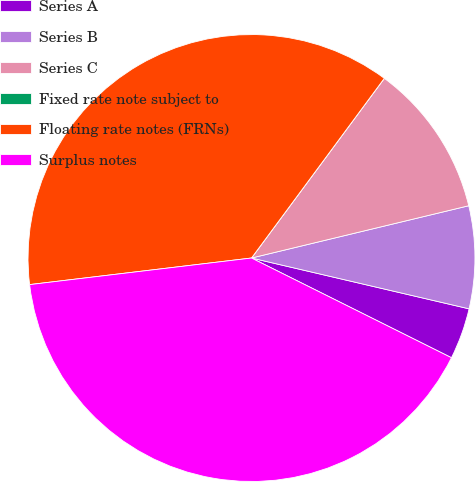Convert chart to OTSL. <chart><loc_0><loc_0><loc_500><loc_500><pie_chart><fcel>Series A<fcel>Series B<fcel>Series C<fcel>Fixed rate note subject to<fcel>Floating rate notes (FRNs)<fcel>Surplus notes<nl><fcel>3.71%<fcel>7.41%<fcel>11.11%<fcel>0.0%<fcel>37.03%<fcel>40.74%<nl></chart> 